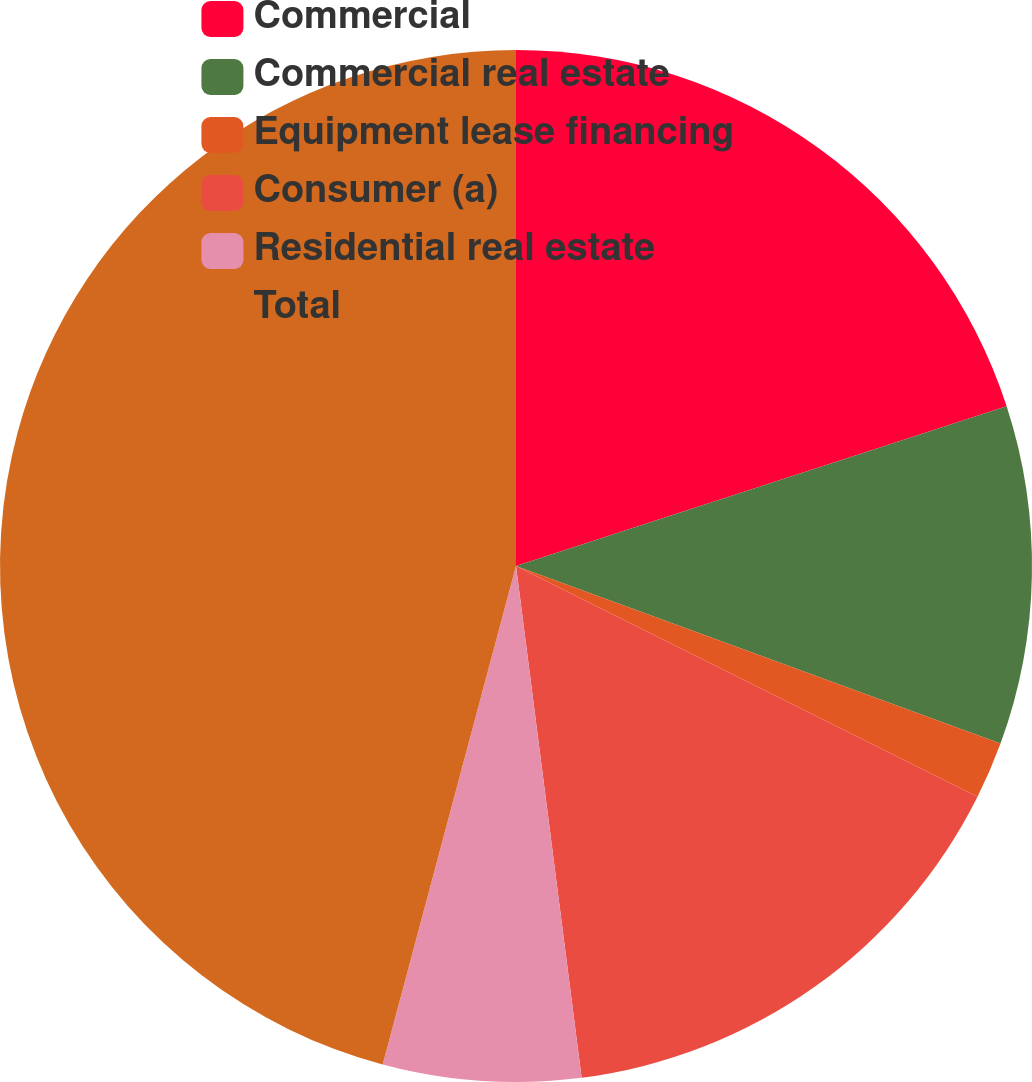<chart> <loc_0><loc_0><loc_500><loc_500><pie_chart><fcel>Commercial<fcel>Commercial real estate<fcel>Equipment lease financing<fcel>Consumer (a)<fcel>Residential real estate<fcel>Total<nl><fcel>19.99%<fcel>10.6%<fcel>1.79%<fcel>15.59%<fcel>6.19%<fcel>45.84%<nl></chart> 